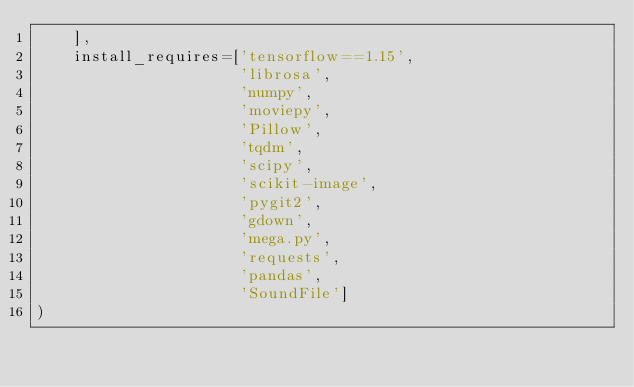Convert code to text. <code><loc_0><loc_0><loc_500><loc_500><_Python_>    ],
    install_requires=['tensorflow==1.15',
                      'librosa',
                      'numpy',
                      'moviepy',
                      'Pillow',
                      'tqdm',
                      'scipy',
                      'scikit-image',
                      'pygit2',
                      'gdown', 
                      'mega.py',
                      'requests',
                      'pandas',
                      'SoundFile']
)
</code> 